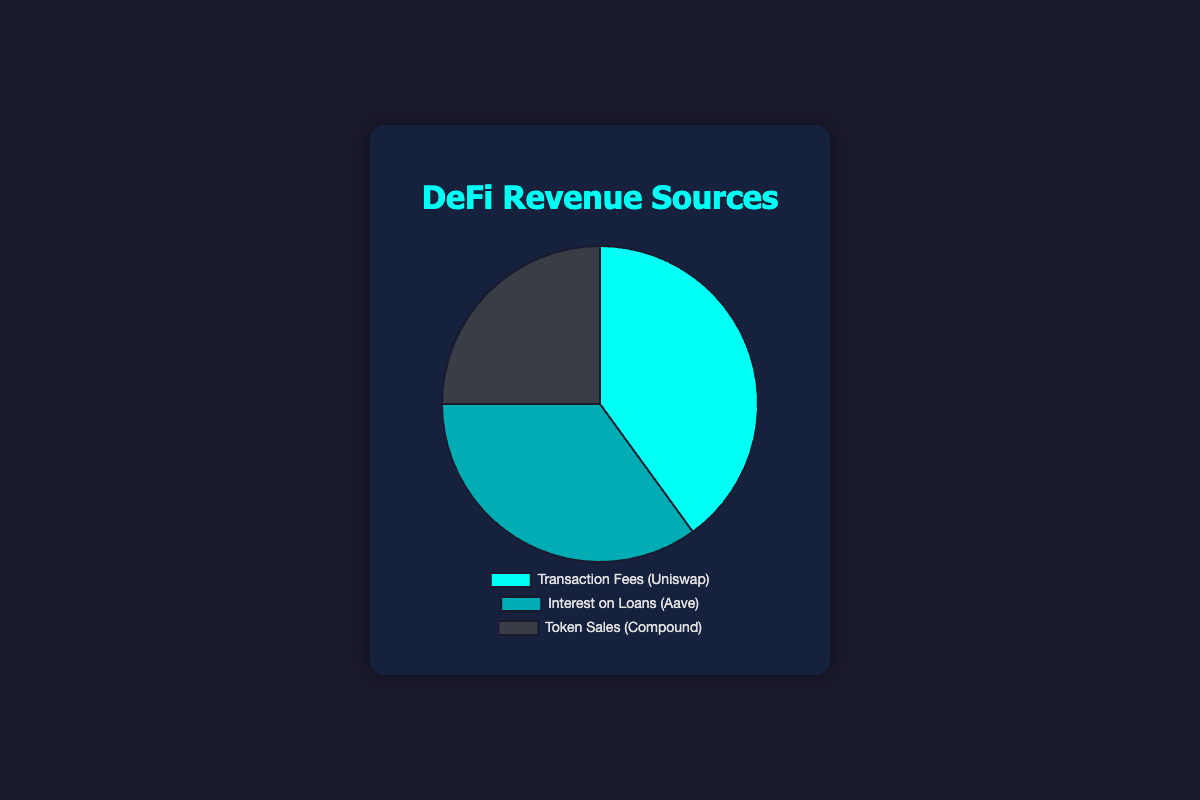Which revenue source generates the most revenue? The pie chart shows the proportions of different revenue sources, and the slice representing 'Transaction Fees (Uniswap)' is the largest. Therefore, 'Transaction Fees' generates the most revenue.
Answer: Transaction Fees How much more revenue does 'Transaction Fees (Uniswap)' generate compared to 'Token Sales (Compound)'? The pie chart indicates 'Transaction Fees (Uniswap)' at 40% and 'Token Sales (Compound)' at 25%. To find the difference: 40% - 25% = 15%.
Answer: 15% What is the combined revenue percentage of 'Interest on Loans (Aave)' and 'Token Sales (Compound)'? The pie chart shows 'Interest on Loans (Aave)' at 35% and 'Token Sales (Compound)' at 25%. To find the total combined percentage: 35% + 25% = 60%.
Answer: 60% Which entities represent each revenue source, and what are their respective revenue contributions? The chart labels indicate:
- Transaction Fees: Uniswap, 40%
- Interest on Loans: Aave, 35%
- Token Sales: Compound, 25%
Answer: Uniswap: 40%, Aave: 35%, Compound: 25% Is the revenue from 'Token Sales (Compound)' more or less than 'Interest on Loans (Aave)'? The pie chart shows the slice for 'Token Sales' at 25% and 'Interest on Loans' at 35%. Therefore, 'Token Sales' generates less revenue than 'Interest on Loans'.
Answer: Less What is the visual distinction of the highest revenue segment in the pie chart? The highest revenue segment, 'Transaction Fees (Uniswap)', is represented by the largest slice, which is typically the most prominent and visually stands out.
Answer: Largest slice How does the revenue from 'Transaction Fees (Uniswap)' compare to the total revenue of the other two sources combined? The pie chart shows 'Transaction Fees' at 40%. Adding the other two sources gives 35% + 25% = 60%. Thus, 'Transaction Fees' contributes less than the combined 'Interest on Loans' and 'Token Sales'.
Answer: Less If the pie chart were to be displayed in a report, which color would represent 'Interest on Loans (Aave)'? From the chart’s appearance and legend, 'Interest on Loans (Aave)' is visually distinguished by a specific color, typically the second color in the legend order. Given the context, it is represented by the medium shade of blue.
Answer: Medium blue What is the average percentage revenue contribution of all three sources? The percentages are 40%, 35%, and 25%. To calculate the average: (40 + 35 + 25) / 3 = 33.33%.
Answer: 33.33% If 'Token Sales (Compound)' were to increase by 10%, how would this affect its standing compared to the other sources? Currently, 'Token Sales (Compound)' is 25%. With a 10% increase, it would become 35%. This new value would equal 'Interest on Loans (Aave)' which is 35%, and still be less than 'Transaction Fees (Uniswap)' at 40%.
Answer: Equal to Aave, less than Uniswap 